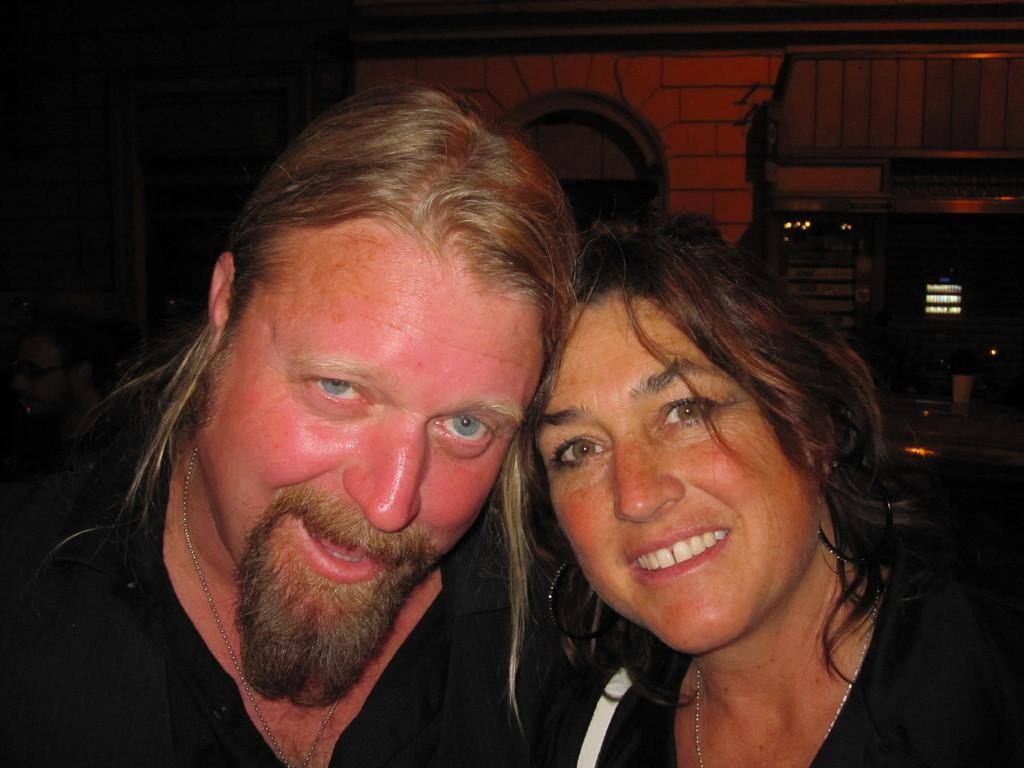What is the main subject of the image? There is a lady in the image. What is the lady wearing? The lady is wearing a black dress. Are there any other people visible in the image? Yes, there is a guy in the image. What is the guy wearing? The guy is wearing a black dress. Can you describe anything visible in the background of the image? There are some other things visible in the background of the image. What type of tramp can be seen in the image? There is no tramp present in the image. What kind of insurance policy is being discussed by the lady and the guy in the image? There is no indication in the image that the lady and the guy are discussing any insurance policy. 